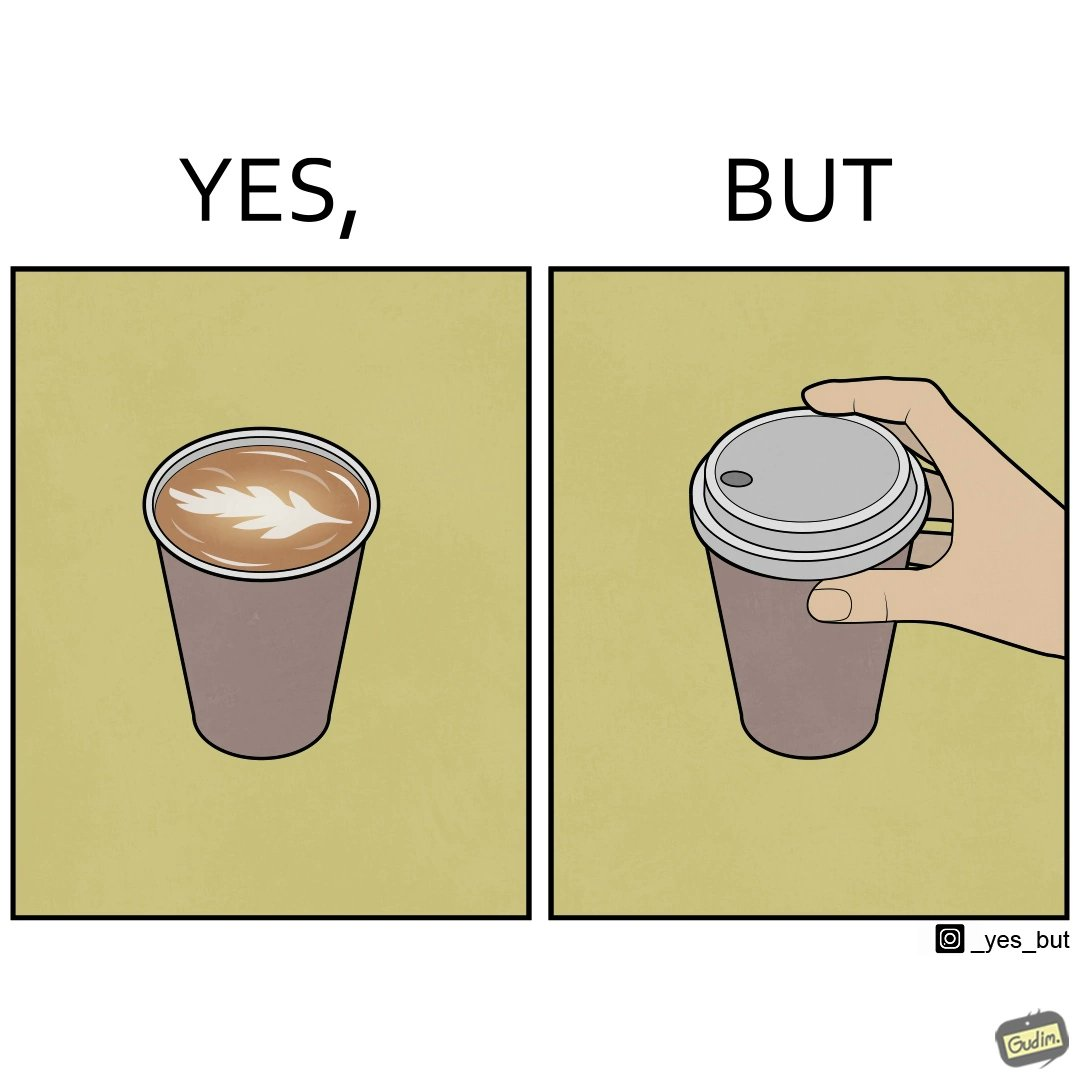What do you see in each half of this image? In the left part of the image: It is a cup of coffee with latte art In the right part of the image: It is a cup of coffee with its lid on top 